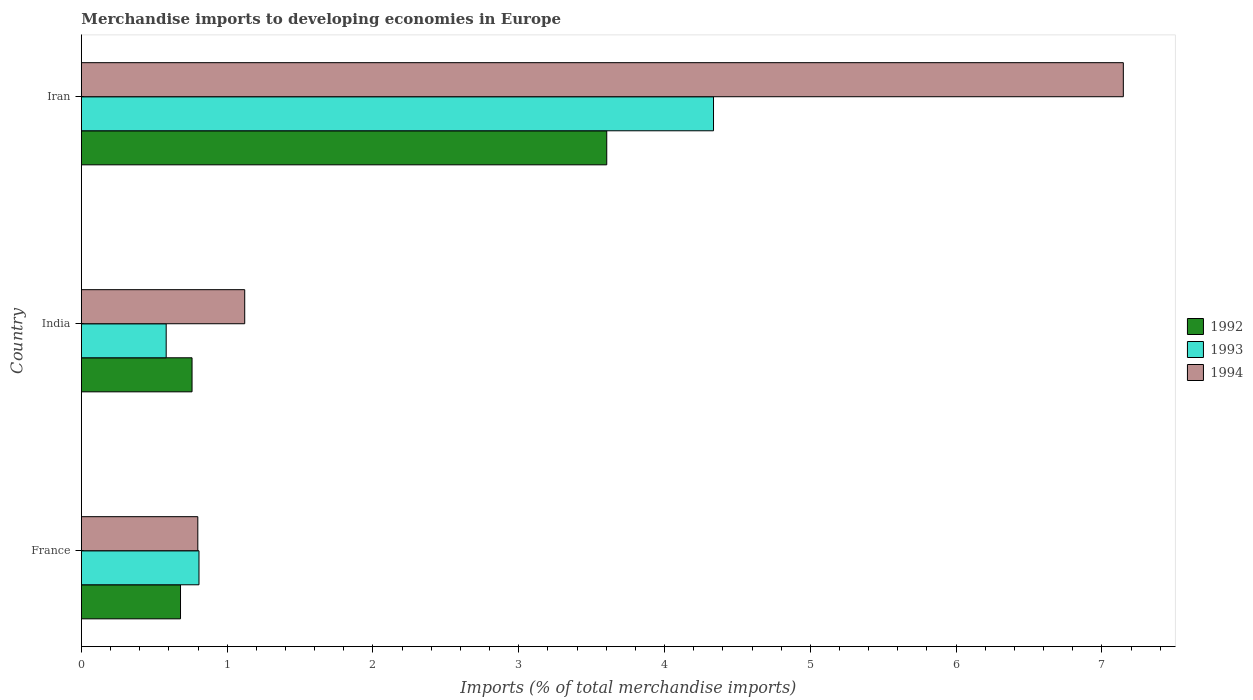How many groups of bars are there?
Your answer should be very brief. 3. Are the number of bars on each tick of the Y-axis equal?
Your response must be concise. Yes. What is the label of the 1st group of bars from the top?
Your response must be concise. Iran. In how many cases, is the number of bars for a given country not equal to the number of legend labels?
Your answer should be compact. 0. What is the percentage total merchandise imports in 1994 in India?
Keep it short and to the point. 1.12. Across all countries, what is the maximum percentage total merchandise imports in 1992?
Provide a short and direct response. 3.6. Across all countries, what is the minimum percentage total merchandise imports in 1994?
Offer a terse response. 0.8. In which country was the percentage total merchandise imports in 1993 maximum?
Your answer should be very brief. Iran. In which country was the percentage total merchandise imports in 1992 minimum?
Offer a very short reply. France. What is the total percentage total merchandise imports in 1993 in the graph?
Ensure brevity in your answer.  5.72. What is the difference between the percentage total merchandise imports in 1994 in India and that in Iran?
Give a very brief answer. -6.03. What is the difference between the percentage total merchandise imports in 1992 in India and the percentage total merchandise imports in 1994 in Iran?
Offer a very short reply. -6.39. What is the average percentage total merchandise imports in 1992 per country?
Keep it short and to the point. 1.68. What is the difference between the percentage total merchandise imports in 1994 and percentage total merchandise imports in 1993 in Iran?
Provide a succinct answer. 2.81. In how many countries, is the percentage total merchandise imports in 1992 greater than 2 %?
Your answer should be compact. 1. What is the ratio of the percentage total merchandise imports in 1993 in France to that in India?
Your response must be concise. 1.39. Is the difference between the percentage total merchandise imports in 1994 in India and Iran greater than the difference between the percentage total merchandise imports in 1993 in India and Iran?
Offer a terse response. No. What is the difference between the highest and the second highest percentage total merchandise imports in 1992?
Your answer should be very brief. 2.84. What is the difference between the highest and the lowest percentage total merchandise imports in 1993?
Provide a succinct answer. 3.75. In how many countries, is the percentage total merchandise imports in 1993 greater than the average percentage total merchandise imports in 1993 taken over all countries?
Make the answer very short. 1. What does the 3rd bar from the bottom in Iran represents?
Offer a very short reply. 1994. Is it the case that in every country, the sum of the percentage total merchandise imports in 1994 and percentage total merchandise imports in 1993 is greater than the percentage total merchandise imports in 1992?
Make the answer very short. Yes. How many bars are there?
Provide a succinct answer. 9. How many countries are there in the graph?
Offer a terse response. 3. Are the values on the major ticks of X-axis written in scientific E-notation?
Keep it short and to the point. No. Does the graph contain any zero values?
Provide a short and direct response. No. Does the graph contain grids?
Your answer should be compact. No. How many legend labels are there?
Keep it short and to the point. 3. What is the title of the graph?
Offer a very short reply. Merchandise imports to developing economies in Europe. What is the label or title of the X-axis?
Keep it short and to the point. Imports (% of total merchandise imports). What is the label or title of the Y-axis?
Give a very brief answer. Country. What is the Imports (% of total merchandise imports) in 1992 in France?
Give a very brief answer. 0.68. What is the Imports (% of total merchandise imports) in 1993 in France?
Offer a terse response. 0.81. What is the Imports (% of total merchandise imports) of 1994 in France?
Your answer should be compact. 0.8. What is the Imports (% of total merchandise imports) in 1992 in India?
Your answer should be compact. 0.76. What is the Imports (% of total merchandise imports) of 1993 in India?
Ensure brevity in your answer.  0.58. What is the Imports (% of total merchandise imports) in 1994 in India?
Offer a very short reply. 1.12. What is the Imports (% of total merchandise imports) in 1992 in Iran?
Provide a succinct answer. 3.6. What is the Imports (% of total merchandise imports) of 1993 in Iran?
Make the answer very short. 4.34. What is the Imports (% of total merchandise imports) of 1994 in Iran?
Provide a short and direct response. 7.15. Across all countries, what is the maximum Imports (% of total merchandise imports) in 1992?
Provide a short and direct response. 3.6. Across all countries, what is the maximum Imports (% of total merchandise imports) of 1993?
Ensure brevity in your answer.  4.34. Across all countries, what is the maximum Imports (% of total merchandise imports) of 1994?
Keep it short and to the point. 7.15. Across all countries, what is the minimum Imports (% of total merchandise imports) in 1992?
Make the answer very short. 0.68. Across all countries, what is the minimum Imports (% of total merchandise imports) of 1993?
Offer a terse response. 0.58. Across all countries, what is the minimum Imports (% of total merchandise imports) of 1994?
Provide a short and direct response. 0.8. What is the total Imports (% of total merchandise imports) of 1992 in the graph?
Give a very brief answer. 5.04. What is the total Imports (% of total merchandise imports) of 1993 in the graph?
Ensure brevity in your answer.  5.72. What is the total Imports (% of total merchandise imports) in 1994 in the graph?
Make the answer very short. 9.07. What is the difference between the Imports (% of total merchandise imports) of 1992 in France and that in India?
Your answer should be very brief. -0.08. What is the difference between the Imports (% of total merchandise imports) in 1993 in France and that in India?
Give a very brief answer. 0.22. What is the difference between the Imports (% of total merchandise imports) in 1994 in France and that in India?
Provide a short and direct response. -0.32. What is the difference between the Imports (% of total merchandise imports) in 1992 in France and that in Iran?
Offer a very short reply. -2.92. What is the difference between the Imports (% of total merchandise imports) of 1993 in France and that in Iran?
Provide a short and direct response. -3.53. What is the difference between the Imports (% of total merchandise imports) in 1994 in France and that in Iran?
Offer a very short reply. -6.35. What is the difference between the Imports (% of total merchandise imports) of 1992 in India and that in Iran?
Offer a very short reply. -2.84. What is the difference between the Imports (% of total merchandise imports) in 1993 in India and that in Iran?
Offer a terse response. -3.75. What is the difference between the Imports (% of total merchandise imports) of 1994 in India and that in Iran?
Your answer should be compact. -6.03. What is the difference between the Imports (% of total merchandise imports) in 1992 in France and the Imports (% of total merchandise imports) in 1993 in India?
Keep it short and to the point. 0.1. What is the difference between the Imports (% of total merchandise imports) in 1992 in France and the Imports (% of total merchandise imports) in 1994 in India?
Provide a short and direct response. -0.44. What is the difference between the Imports (% of total merchandise imports) of 1993 in France and the Imports (% of total merchandise imports) of 1994 in India?
Ensure brevity in your answer.  -0.31. What is the difference between the Imports (% of total merchandise imports) of 1992 in France and the Imports (% of total merchandise imports) of 1993 in Iran?
Give a very brief answer. -3.66. What is the difference between the Imports (% of total merchandise imports) of 1992 in France and the Imports (% of total merchandise imports) of 1994 in Iran?
Offer a very short reply. -6.47. What is the difference between the Imports (% of total merchandise imports) in 1993 in France and the Imports (% of total merchandise imports) in 1994 in Iran?
Your answer should be compact. -6.34. What is the difference between the Imports (% of total merchandise imports) in 1992 in India and the Imports (% of total merchandise imports) in 1993 in Iran?
Offer a terse response. -3.58. What is the difference between the Imports (% of total merchandise imports) in 1992 in India and the Imports (% of total merchandise imports) in 1994 in Iran?
Provide a succinct answer. -6.39. What is the difference between the Imports (% of total merchandise imports) in 1993 in India and the Imports (% of total merchandise imports) in 1994 in Iran?
Your answer should be compact. -6.57. What is the average Imports (% of total merchandise imports) of 1992 per country?
Offer a very short reply. 1.68. What is the average Imports (% of total merchandise imports) of 1993 per country?
Offer a terse response. 1.91. What is the average Imports (% of total merchandise imports) of 1994 per country?
Give a very brief answer. 3.02. What is the difference between the Imports (% of total merchandise imports) in 1992 and Imports (% of total merchandise imports) in 1993 in France?
Provide a short and direct response. -0.13. What is the difference between the Imports (% of total merchandise imports) of 1992 and Imports (% of total merchandise imports) of 1994 in France?
Your response must be concise. -0.12. What is the difference between the Imports (% of total merchandise imports) in 1993 and Imports (% of total merchandise imports) in 1994 in France?
Your response must be concise. 0.01. What is the difference between the Imports (% of total merchandise imports) of 1992 and Imports (% of total merchandise imports) of 1993 in India?
Make the answer very short. 0.18. What is the difference between the Imports (% of total merchandise imports) of 1992 and Imports (% of total merchandise imports) of 1994 in India?
Your answer should be compact. -0.36. What is the difference between the Imports (% of total merchandise imports) of 1993 and Imports (% of total merchandise imports) of 1994 in India?
Give a very brief answer. -0.54. What is the difference between the Imports (% of total merchandise imports) in 1992 and Imports (% of total merchandise imports) in 1993 in Iran?
Your answer should be compact. -0.73. What is the difference between the Imports (% of total merchandise imports) in 1992 and Imports (% of total merchandise imports) in 1994 in Iran?
Your response must be concise. -3.54. What is the difference between the Imports (% of total merchandise imports) of 1993 and Imports (% of total merchandise imports) of 1994 in Iran?
Make the answer very short. -2.81. What is the ratio of the Imports (% of total merchandise imports) of 1992 in France to that in India?
Your answer should be compact. 0.9. What is the ratio of the Imports (% of total merchandise imports) of 1993 in France to that in India?
Offer a very short reply. 1.39. What is the ratio of the Imports (% of total merchandise imports) of 1994 in France to that in India?
Provide a short and direct response. 0.71. What is the ratio of the Imports (% of total merchandise imports) of 1992 in France to that in Iran?
Make the answer very short. 0.19. What is the ratio of the Imports (% of total merchandise imports) in 1993 in France to that in Iran?
Give a very brief answer. 0.19. What is the ratio of the Imports (% of total merchandise imports) in 1994 in France to that in Iran?
Your answer should be compact. 0.11. What is the ratio of the Imports (% of total merchandise imports) in 1992 in India to that in Iran?
Ensure brevity in your answer.  0.21. What is the ratio of the Imports (% of total merchandise imports) in 1993 in India to that in Iran?
Offer a very short reply. 0.13. What is the ratio of the Imports (% of total merchandise imports) of 1994 in India to that in Iran?
Provide a succinct answer. 0.16. What is the difference between the highest and the second highest Imports (% of total merchandise imports) of 1992?
Give a very brief answer. 2.84. What is the difference between the highest and the second highest Imports (% of total merchandise imports) of 1993?
Your response must be concise. 3.53. What is the difference between the highest and the second highest Imports (% of total merchandise imports) of 1994?
Ensure brevity in your answer.  6.03. What is the difference between the highest and the lowest Imports (% of total merchandise imports) of 1992?
Your answer should be compact. 2.92. What is the difference between the highest and the lowest Imports (% of total merchandise imports) in 1993?
Your answer should be very brief. 3.75. What is the difference between the highest and the lowest Imports (% of total merchandise imports) of 1994?
Keep it short and to the point. 6.35. 